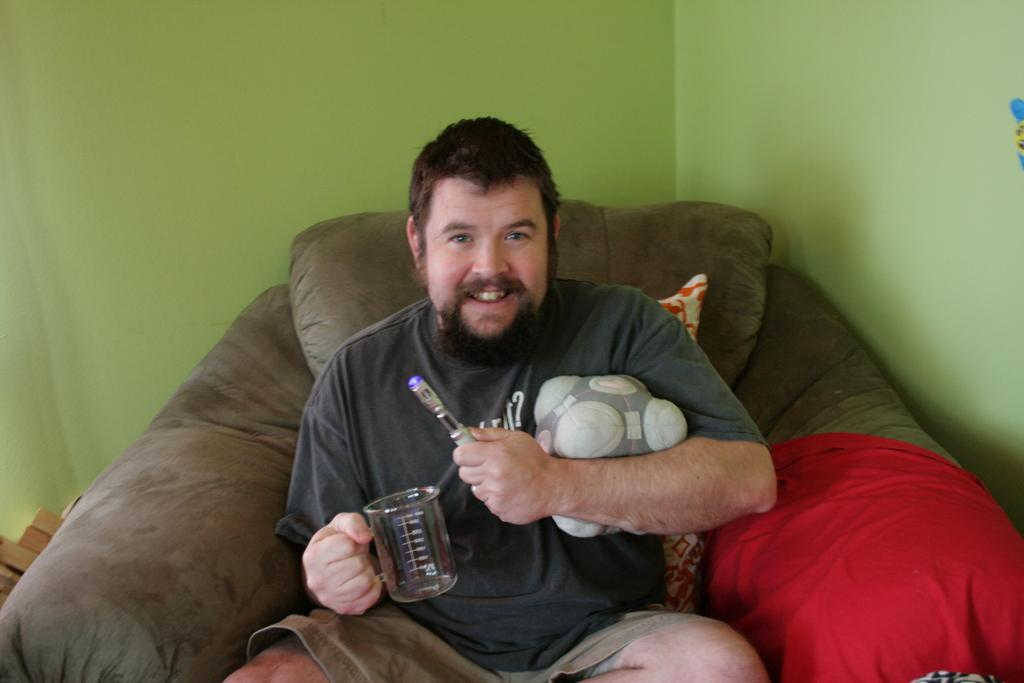Who is present in the image? There is a man in the image. What is the man doing in the image? The man is sitting on a recliner. What is the man holding in the image? The man is holding a glass. What can be seen behind the man in the image? There is a wall behind the man. How does the man stop the room from spinning in the image? There is no indication in the image that the room is spinning, and the man is not attempting to stop it. 